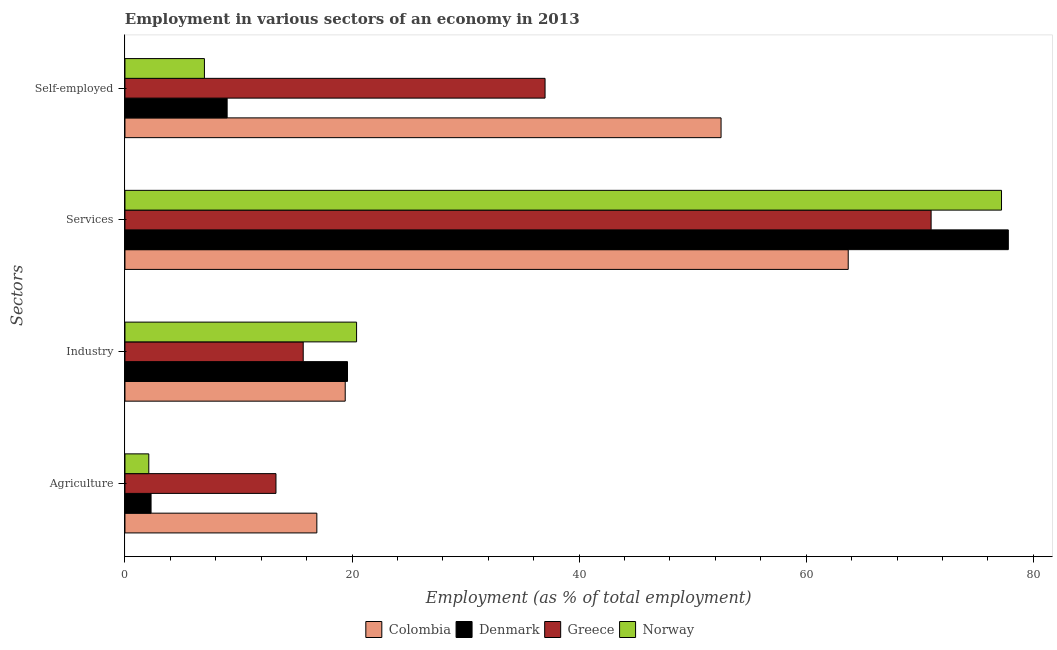How many groups of bars are there?
Your response must be concise. 4. Are the number of bars on each tick of the Y-axis equal?
Give a very brief answer. Yes. How many bars are there on the 1st tick from the top?
Give a very brief answer. 4. What is the label of the 3rd group of bars from the top?
Offer a terse response. Industry. What is the percentage of self employed workers in Norway?
Ensure brevity in your answer.  7. Across all countries, what is the maximum percentage of workers in industry?
Keep it short and to the point. 20.4. In which country was the percentage of workers in industry maximum?
Ensure brevity in your answer.  Norway. What is the total percentage of self employed workers in the graph?
Keep it short and to the point. 105.5. What is the difference between the percentage of workers in industry in Denmark and that in Greece?
Provide a short and direct response. 3.9. What is the difference between the percentage of workers in services in Greece and the percentage of workers in agriculture in Denmark?
Keep it short and to the point. 68.7. What is the average percentage of workers in agriculture per country?
Offer a terse response. 8.65. What is the difference between the percentage of workers in services and percentage of workers in agriculture in Greece?
Provide a short and direct response. 57.7. What is the ratio of the percentage of workers in services in Denmark to that in Norway?
Your answer should be very brief. 1.01. Is the percentage of workers in agriculture in Denmark less than that in Greece?
Offer a terse response. Yes. What is the difference between the highest and the second highest percentage of workers in agriculture?
Your answer should be compact. 3.6. What is the difference between the highest and the lowest percentage of workers in agriculture?
Your answer should be very brief. 14.8. Is the sum of the percentage of workers in services in Norway and Greece greater than the maximum percentage of self employed workers across all countries?
Ensure brevity in your answer.  Yes. Is it the case that in every country, the sum of the percentage of workers in agriculture and percentage of self employed workers is greater than the sum of percentage of workers in services and percentage of workers in industry?
Ensure brevity in your answer.  No. Are all the bars in the graph horizontal?
Provide a short and direct response. Yes. How many countries are there in the graph?
Ensure brevity in your answer.  4. What is the difference between two consecutive major ticks on the X-axis?
Offer a very short reply. 20. How are the legend labels stacked?
Your response must be concise. Horizontal. What is the title of the graph?
Your response must be concise. Employment in various sectors of an economy in 2013. Does "Central Europe" appear as one of the legend labels in the graph?
Make the answer very short. No. What is the label or title of the X-axis?
Keep it short and to the point. Employment (as % of total employment). What is the label or title of the Y-axis?
Give a very brief answer. Sectors. What is the Employment (as % of total employment) of Colombia in Agriculture?
Ensure brevity in your answer.  16.9. What is the Employment (as % of total employment) of Denmark in Agriculture?
Ensure brevity in your answer.  2.3. What is the Employment (as % of total employment) of Greece in Agriculture?
Give a very brief answer. 13.3. What is the Employment (as % of total employment) of Norway in Agriculture?
Your answer should be very brief. 2.1. What is the Employment (as % of total employment) in Colombia in Industry?
Offer a very short reply. 19.4. What is the Employment (as % of total employment) in Denmark in Industry?
Your response must be concise. 19.6. What is the Employment (as % of total employment) of Greece in Industry?
Your response must be concise. 15.7. What is the Employment (as % of total employment) of Norway in Industry?
Provide a succinct answer. 20.4. What is the Employment (as % of total employment) of Colombia in Services?
Offer a very short reply. 63.7. What is the Employment (as % of total employment) in Denmark in Services?
Provide a short and direct response. 77.8. What is the Employment (as % of total employment) in Greece in Services?
Your answer should be compact. 71. What is the Employment (as % of total employment) of Norway in Services?
Offer a very short reply. 77.2. What is the Employment (as % of total employment) in Colombia in Self-employed?
Provide a succinct answer. 52.5. What is the Employment (as % of total employment) of Denmark in Self-employed?
Keep it short and to the point. 9. What is the Employment (as % of total employment) of Greece in Self-employed?
Make the answer very short. 37. Across all Sectors, what is the maximum Employment (as % of total employment) of Colombia?
Your answer should be very brief. 63.7. Across all Sectors, what is the maximum Employment (as % of total employment) in Denmark?
Provide a short and direct response. 77.8. Across all Sectors, what is the maximum Employment (as % of total employment) in Greece?
Offer a very short reply. 71. Across all Sectors, what is the maximum Employment (as % of total employment) in Norway?
Keep it short and to the point. 77.2. Across all Sectors, what is the minimum Employment (as % of total employment) in Colombia?
Offer a very short reply. 16.9. Across all Sectors, what is the minimum Employment (as % of total employment) of Denmark?
Provide a short and direct response. 2.3. Across all Sectors, what is the minimum Employment (as % of total employment) in Greece?
Make the answer very short. 13.3. Across all Sectors, what is the minimum Employment (as % of total employment) of Norway?
Keep it short and to the point. 2.1. What is the total Employment (as % of total employment) in Colombia in the graph?
Make the answer very short. 152.5. What is the total Employment (as % of total employment) of Denmark in the graph?
Provide a succinct answer. 108.7. What is the total Employment (as % of total employment) in Greece in the graph?
Provide a short and direct response. 137. What is the total Employment (as % of total employment) in Norway in the graph?
Your response must be concise. 106.7. What is the difference between the Employment (as % of total employment) of Colombia in Agriculture and that in Industry?
Make the answer very short. -2.5. What is the difference between the Employment (as % of total employment) of Denmark in Agriculture and that in Industry?
Your response must be concise. -17.3. What is the difference between the Employment (as % of total employment) of Norway in Agriculture and that in Industry?
Your answer should be compact. -18.3. What is the difference between the Employment (as % of total employment) in Colombia in Agriculture and that in Services?
Make the answer very short. -46.8. What is the difference between the Employment (as % of total employment) in Denmark in Agriculture and that in Services?
Give a very brief answer. -75.5. What is the difference between the Employment (as % of total employment) in Greece in Agriculture and that in Services?
Offer a terse response. -57.7. What is the difference between the Employment (as % of total employment) in Norway in Agriculture and that in Services?
Provide a short and direct response. -75.1. What is the difference between the Employment (as % of total employment) in Colombia in Agriculture and that in Self-employed?
Provide a short and direct response. -35.6. What is the difference between the Employment (as % of total employment) of Denmark in Agriculture and that in Self-employed?
Offer a very short reply. -6.7. What is the difference between the Employment (as % of total employment) in Greece in Agriculture and that in Self-employed?
Provide a short and direct response. -23.7. What is the difference between the Employment (as % of total employment) in Norway in Agriculture and that in Self-employed?
Your answer should be compact. -4.9. What is the difference between the Employment (as % of total employment) of Colombia in Industry and that in Services?
Give a very brief answer. -44.3. What is the difference between the Employment (as % of total employment) of Denmark in Industry and that in Services?
Give a very brief answer. -58.2. What is the difference between the Employment (as % of total employment) in Greece in Industry and that in Services?
Ensure brevity in your answer.  -55.3. What is the difference between the Employment (as % of total employment) of Norway in Industry and that in Services?
Give a very brief answer. -56.8. What is the difference between the Employment (as % of total employment) in Colombia in Industry and that in Self-employed?
Give a very brief answer. -33.1. What is the difference between the Employment (as % of total employment) in Greece in Industry and that in Self-employed?
Your answer should be very brief. -21.3. What is the difference between the Employment (as % of total employment) of Colombia in Services and that in Self-employed?
Give a very brief answer. 11.2. What is the difference between the Employment (as % of total employment) of Denmark in Services and that in Self-employed?
Your response must be concise. 68.8. What is the difference between the Employment (as % of total employment) in Norway in Services and that in Self-employed?
Provide a short and direct response. 70.2. What is the difference between the Employment (as % of total employment) in Denmark in Agriculture and the Employment (as % of total employment) in Norway in Industry?
Provide a short and direct response. -18.1. What is the difference between the Employment (as % of total employment) of Colombia in Agriculture and the Employment (as % of total employment) of Denmark in Services?
Offer a terse response. -60.9. What is the difference between the Employment (as % of total employment) of Colombia in Agriculture and the Employment (as % of total employment) of Greece in Services?
Provide a succinct answer. -54.1. What is the difference between the Employment (as % of total employment) of Colombia in Agriculture and the Employment (as % of total employment) of Norway in Services?
Your response must be concise. -60.3. What is the difference between the Employment (as % of total employment) of Denmark in Agriculture and the Employment (as % of total employment) of Greece in Services?
Make the answer very short. -68.7. What is the difference between the Employment (as % of total employment) of Denmark in Agriculture and the Employment (as % of total employment) of Norway in Services?
Offer a very short reply. -74.9. What is the difference between the Employment (as % of total employment) of Greece in Agriculture and the Employment (as % of total employment) of Norway in Services?
Provide a short and direct response. -63.9. What is the difference between the Employment (as % of total employment) of Colombia in Agriculture and the Employment (as % of total employment) of Denmark in Self-employed?
Keep it short and to the point. 7.9. What is the difference between the Employment (as % of total employment) of Colombia in Agriculture and the Employment (as % of total employment) of Greece in Self-employed?
Your answer should be compact. -20.1. What is the difference between the Employment (as % of total employment) of Colombia in Agriculture and the Employment (as % of total employment) of Norway in Self-employed?
Make the answer very short. 9.9. What is the difference between the Employment (as % of total employment) of Denmark in Agriculture and the Employment (as % of total employment) of Greece in Self-employed?
Ensure brevity in your answer.  -34.7. What is the difference between the Employment (as % of total employment) of Greece in Agriculture and the Employment (as % of total employment) of Norway in Self-employed?
Provide a succinct answer. 6.3. What is the difference between the Employment (as % of total employment) in Colombia in Industry and the Employment (as % of total employment) in Denmark in Services?
Keep it short and to the point. -58.4. What is the difference between the Employment (as % of total employment) in Colombia in Industry and the Employment (as % of total employment) in Greece in Services?
Provide a short and direct response. -51.6. What is the difference between the Employment (as % of total employment) of Colombia in Industry and the Employment (as % of total employment) of Norway in Services?
Your response must be concise. -57.8. What is the difference between the Employment (as % of total employment) in Denmark in Industry and the Employment (as % of total employment) in Greece in Services?
Make the answer very short. -51.4. What is the difference between the Employment (as % of total employment) in Denmark in Industry and the Employment (as % of total employment) in Norway in Services?
Keep it short and to the point. -57.6. What is the difference between the Employment (as % of total employment) in Greece in Industry and the Employment (as % of total employment) in Norway in Services?
Give a very brief answer. -61.5. What is the difference between the Employment (as % of total employment) of Colombia in Industry and the Employment (as % of total employment) of Greece in Self-employed?
Provide a short and direct response. -17.6. What is the difference between the Employment (as % of total employment) of Colombia in Industry and the Employment (as % of total employment) of Norway in Self-employed?
Offer a very short reply. 12.4. What is the difference between the Employment (as % of total employment) of Denmark in Industry and the Employment (as % of total employment) of Greece in Self-employed?
Ensure brevity in your answer.  -17.4. What is the difference between the Employment (as % of total employment) of Denmark in Industry and the Employment (as % of total employment) of Norway in Self-employed?
Provide a short and direct response. 12.6. What is the difference between the Employment (as % of total employment) of Greece in Industry and the Employment (as % of total employment) of Norway in Self-employed?
Provide a succinct answer. 8.7. What is the difference between the Employment (as % of total employment) in Colombia in Services and the Employment (as % of total employment) in Denmark in Self-employed?
Your answer should be very brief. 54.7. What is the difference between the Employment (as % of total employment) of Colombia in Services and the Employment (as % of total employment) of Greece in Self-employed?
Your response must be concise. 26.7. What is the difference between the Employment (as % of total employment) of Colombia in Services and the Employment (as % of total employment) of Norway in Self-employed?
Provide a short and direct response. 56.7. What is the difference between the Employment (as % of total employment) in Denmark in Services and the Employment (as % of total employment) in Greece in Self-employed?
Provide a succinct answer. 40.8. What is the difference between the Employment (as % of total employment) of Denmark in Services and the Employment (as % of total employment) of Norway in Self-employed?
Offer a very short reply. 70.8. What is the average Employment (as % of total employment) of Colombia per Sectors?
Give a very brief answer. 38.12. What is the average Employment (as % of total employment) in Denmark per Sectors?
Offer a very short reply. 27.18. What is the average Employment (as % of total employment) in Greece per Sectors?
Offer a very short reply. 34.25. What is the average Employment (as % of total employment) of Norway per Sectors?
Make the answer very short. 26.68. What is the difference between the Employment (as % of total employment) in Denmark and Employment (as % of total employment) in Norway in Agriculture?
Your answer should be compact. 0.2. What is the difference between the Employment (as % of total employment) in Colombia and Employment (as % of total employment) in Greece in Industry?
Your answer should be compact. 3.7. What is the difference between the Employment (as % of total employment) in Denmark and Employment (as % of total employment) in Greece in Industry?
Give a very brief answer. 3.9. What is the difference between the Employment (as % of total employment) in Denmark and Employment (as % of total employment) in Norway in Industry?
Your answer should be very brief. -0.8. What is the difference between the Employment (as % of total employment) of Greece and Employment (as % of total employment) of Norway in Industry?
Your answer should be very brief. -4.7. What is the difference between the Employment (as % of total employment) of Colombia and Employment (as % of total employment) of Denmark in Services?
Offer a very short reply. -14.1. What is the difference between the Employment (as % of total employment) of Colombia and Employment (as % of total employment) of Greece in Services?
Your response must be concise. -7.3. What is the difference between the Employment (as % of total employment) in Denmark and Employment (as % of total employment) in Greece in Services?
Offer a very short reply. 6.8. What is the difference between the Employment (as % of total employment) in Colombia and Employment (as % of total employment) in Denmark in Self-employed?
Your response must be concise. 43.5. What is the difference between the Employment (as % of total employment) in Colombia and Employment (as % of total employment) in Norway in Self-employed?
Your answer should be compact. 45.5. What is the difference between the Employment (as % of total employment) of Denmark and Employment (as % of total employment) of Norway in Self-employed?
Your answer should be compact. 2. What is the difference between the Employment (as % of total employment) of Greece and Employment (as % of total employment) of Norway in Self-employed?
Offer a very short reply. 30. What is the ratio of the Employment (as % of total employment) of Colombia in Agriculture to that in Industry?
Offer a very short reply. 0.87. What is the ratio of the Employment (as % of total employment) in Denmark in Agriculture to that in Industry?
Keep it short and to the point. 0.12. What is the ratio of the Employment (as % of total employment) of Greece in Agriculture to that in Industry?
Give a very brief answer. 0.85. What is the ratio of the Employment (as % of total employment) in Norway in Agriculture to that in Industry?
Your answer should be compact. 0.1. What is the ratio of the Employment (as % of total employment) of Colombia in Agriculture to that in Services?
Keep it short and to the point. 0.27. What is the ratio of the Employment (as % of total employment) in Denmark in Agriculture to that in Services?
Offer a very short reply. 0.03. What is the ratio of the Employment (as % of total employment) of Greece in Agriculture to that in Services?
Ensure brevity in your answer.  0.19. What is the ratio of the Employment (as % of total employment) in Norway in Agriculture to that in Services?
Ensure brevity in your answer.  0.03. What is the ratio of the Employment (as % of total employment) in Colombia in Agriculture to that in Self-employed?
Keep it short and to the point. 0.32. What is the ratio of the Employment (as % of total employment) in Denmark in Agriculture to that in Self-employed?
Offer a terse response. 0.26. What is the ratio of the Employment (as % of total employment) of Greece in Agriculture to that in Self-employed?
Ensure brevity in your answer.  0.36. What is the ratio of the Employment (as % of total employment) of Norway in Agriculture to that in Self-employed?
Your answer should be compact. 0.3. What is the ratio of the Employment (as % of total employment) of Colombia in Industry to that in Services?
Your response must be concise. 0.3. What is the ratio of the Employment (as % of total employment) of Denmark in Industry to that in Services?
Provide a succinct answer. 0.25. What is the ratio of the Employment (as % of total employment) of Greece in Industry to that in Services?
Your answer should be very brief. 0.22. What is the ratio of the Employment (as % of total employment) of Norway in Industry to that in Services?
Ensure brevity in your answer.  0.26. What is the ratio of the Employment (as % of total employment) in Colombia in Industry to that in Self-employed?
Provide a succinct answer. 0.37. What is the ratio of the Employment (as % of total employment) in Denmark in Industry to that in Self-employed?
Your answer should be compact. 2.18. What is the ratio of the Employment (as % of total employment) of Greece in Industry to that in Self-employed?
Provide a short and direct response. 0.42. What is the ratio of the Employment (as % of total employment) of Norway in Industry to that in Self-employed?
Your response must be concise. 2.91. What is the ratio of the Employment (as % of total employment) of Colombia in Services to that in Self-employed?
Your answer should be compact. 1.21. What is the ratio of the Employment (as % of total employment) in Denmark in Services to that in Self-employed?
Keep it short and to the point. 8.64. What is the ratio of the Employment (as % of total employment) of Greece in Services to that in Self-employed?
Your answer should be very brief. 1.92. What is the ratio of the Employment (as % of total employment) of Norway in Services to that in Self-employed?
Offer a very short reply. 11.03. What is the difference between the highest and the second highest Employment (as % of total employment) of Colombia?
Your response must be concise. 11.2. What is the difference between the highest and the second highest Employment (as % of total employment) in Denmark?
Make the answer very short. 58.2. What is the difference between the highest and the second highest Employment (as % of total employment) in Greece?
Give a very brief answer. 34. What is the difference between the highest and the second highest Employment (as % of total employment) in Norway?
Your answer should be very brief. 56.8. What is the difference between the highest and the lowest Employment (as % of total employment) in Colombia?
Ensure brevity in your answer.  46.8. What is the difference between the highest and the lowest Employment (as % of total employment) of Denmark?
Ensure brevity in your answer.  75.5. What is the difference between the highest and the lowest Employment (as % of total employment) of Greece?
Make the answer very short. 57.7. What is the difference between the highest and the lowest Employment (as % of total employment) of Norway?
Ensure brevity in your answer.  75.1. 